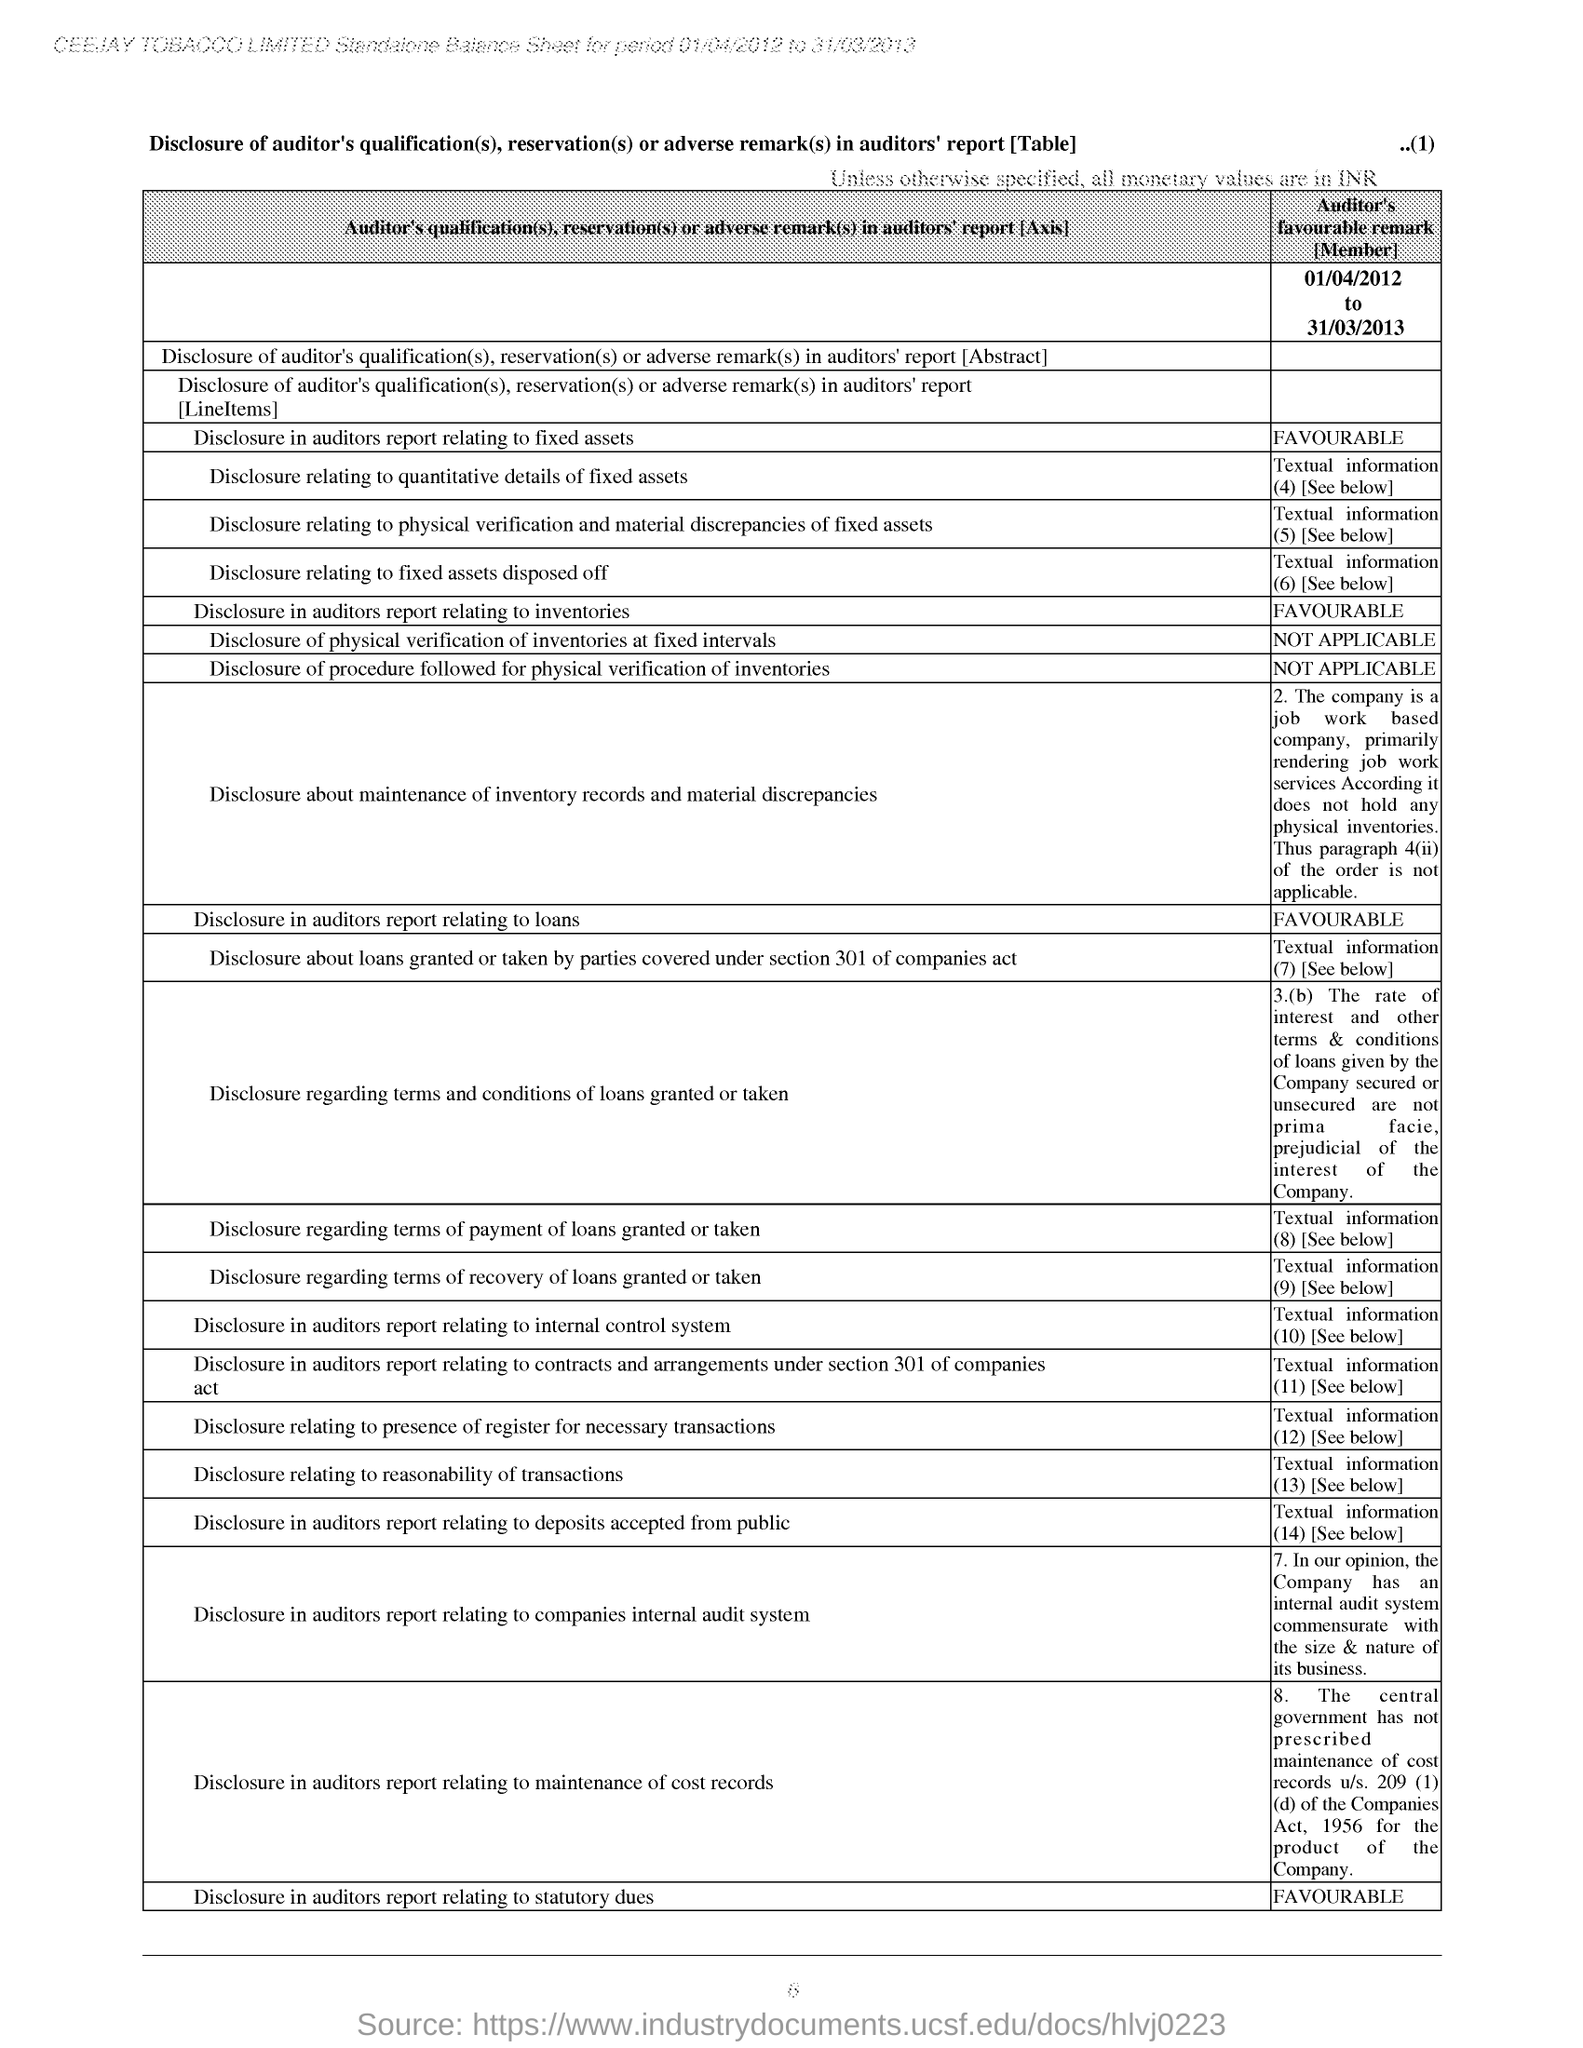Identify some key points in this picture. CEEJAY TOBACCO LIMITED is mentioned at the top of the page. The last disclosure in the balance sheet is "Disclosure in auditors report relating to statutory dues. The page number located at the top right corner of the page is (1). The auditor's remark regarding disclosure in the auditor's report related to loans is favorable. The auditor's remark regarding the disclosure in the auditor's report concerning fixed assets is favorable. 